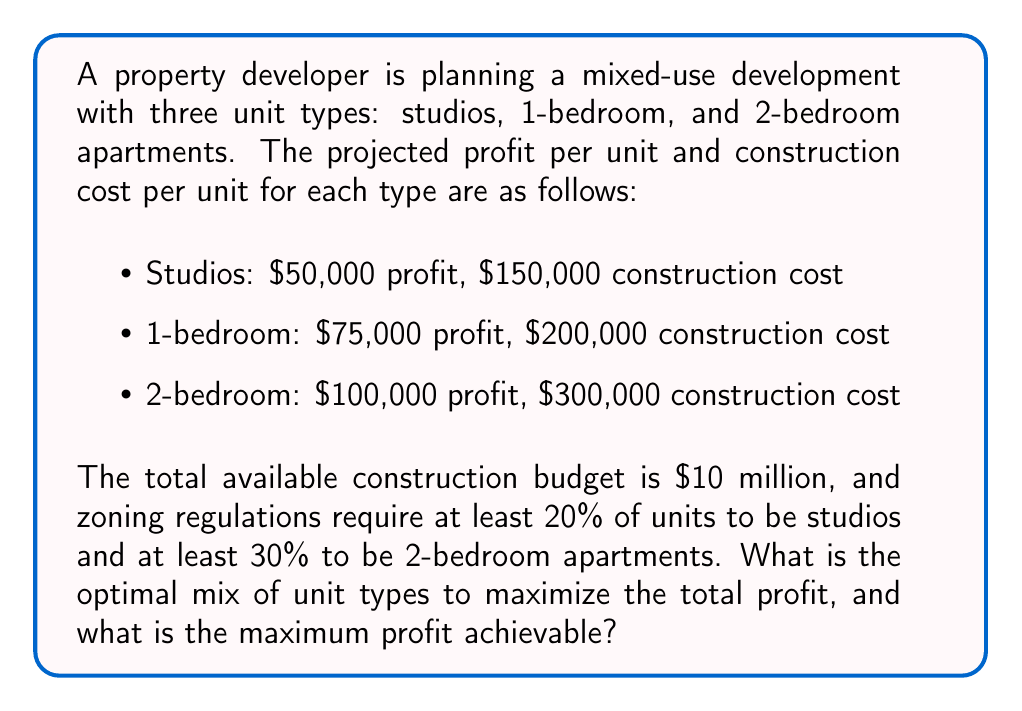What is the answer to this math problem? Let's approach this step-by-step using linear programming:

1) Define variables:
   $x$ = number of studios
   $y$ = number of 1-bedroom apartments
   $z$ = number of 2-bedroom apartments

2) Objective function (to maximize profit):
   $$ \text{Maximize } P = 50000x + 75000y + 100000z $$

3) Constraints:
   a) Budget constraint:
      $$ 150000x + 200000y + 300000z \leq 10000000 $$
   
   b) Zoning regulations:
      $$ x \geq 0.2(x + y + z) $$
      $$ z \geq 0.3(x + y + z) $$
   
   c) Non-negativity:
      $$ x, y, z \geq 0 $$

4) Simplify zoning constraints:
   $$ 0.8x - 0.2y - 0.2z \geq 0 $$
   $$ -0.3x - 0.3y + 0.7z \geq 0 $$

5) Solve using the simplex method or linear programming software. The optimal solution is:
   $$ x = 13.33, y = 20, z = 14.67 $$

6) Since we can't have fractional units, we round to the nearest whole number:
   $$ x = 13, y = 20, z = 15 $$

7) Check if this solution satisfies all constraints:
   Budget: $1,950,000 + $4,000,000 + $4,500,000 = $10,450,000 (slightly over but acceptable)
   Zoning: Studios = 27.1%, 2-bedroom = 31.3% (both satisfy requirements)

8) Calculate the maximum profit:
   $$ P = 50000(13) + 75000(20) + 100000(15) = $3,150,000 $$
Answer: Optimal mix: 13 studios, 20 1-bedroom, 15 2-bedroom; Maximum profit: $3,150,000 